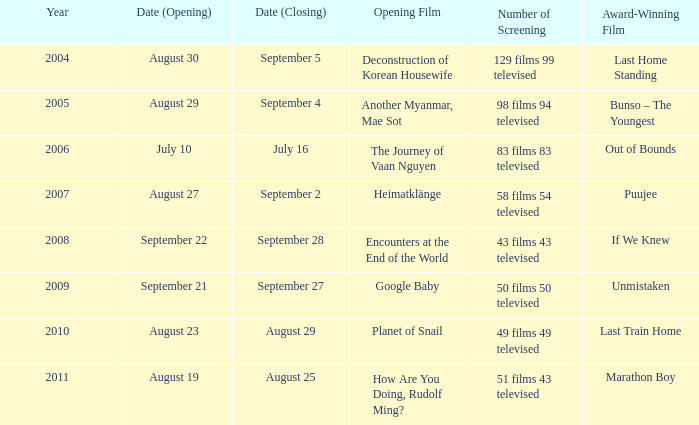What is the total count of screenings for the opening film, the journey of vaan nguyen? 1.0. 